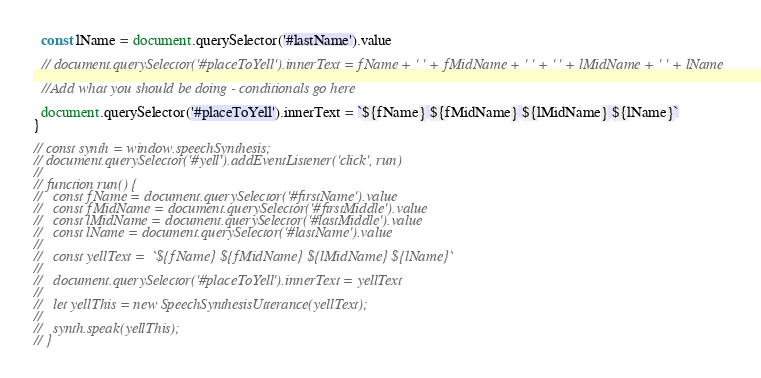<code> <loc_0><loc_0><loc_500><loc_500><_JavaScript_>  const lName = document.querySelector('#lastName').value

  // document.querySelector('#placeToYell').innerText = fName + ' ' + fMidName + ' ' + ' ' + lMidName + ' ' + lName

  //Add what you should be doing - conditionals go here

  document.querySelector('#placeToYell').innerText = `${fName} ${fMidName} ${lMidName} ${lName}`
}

// const synth = window.speechSynthesis;
// document.querySelector('#yell').addEventListener('click', run)
//
// function run() {
//   const fName = document.querySelector('#firstName').value
//   const fMidName = document.querySelector('#firstMiddle').value
//   const lMidName = document.querySelector('#lastMiddle').value
//   const lName = document.querySelector('#lastName').value
//
//   const yellText =  `${fName} ${fMidName} ${lMidName} ${lName}`
//
//   document.querySelector('#placeToYell').innerText = yellText
//
//   let yellThis = new SpeechSynthesisUtterance(yellText);
//
//   synth.speak(yellThis);
// }
</code> 